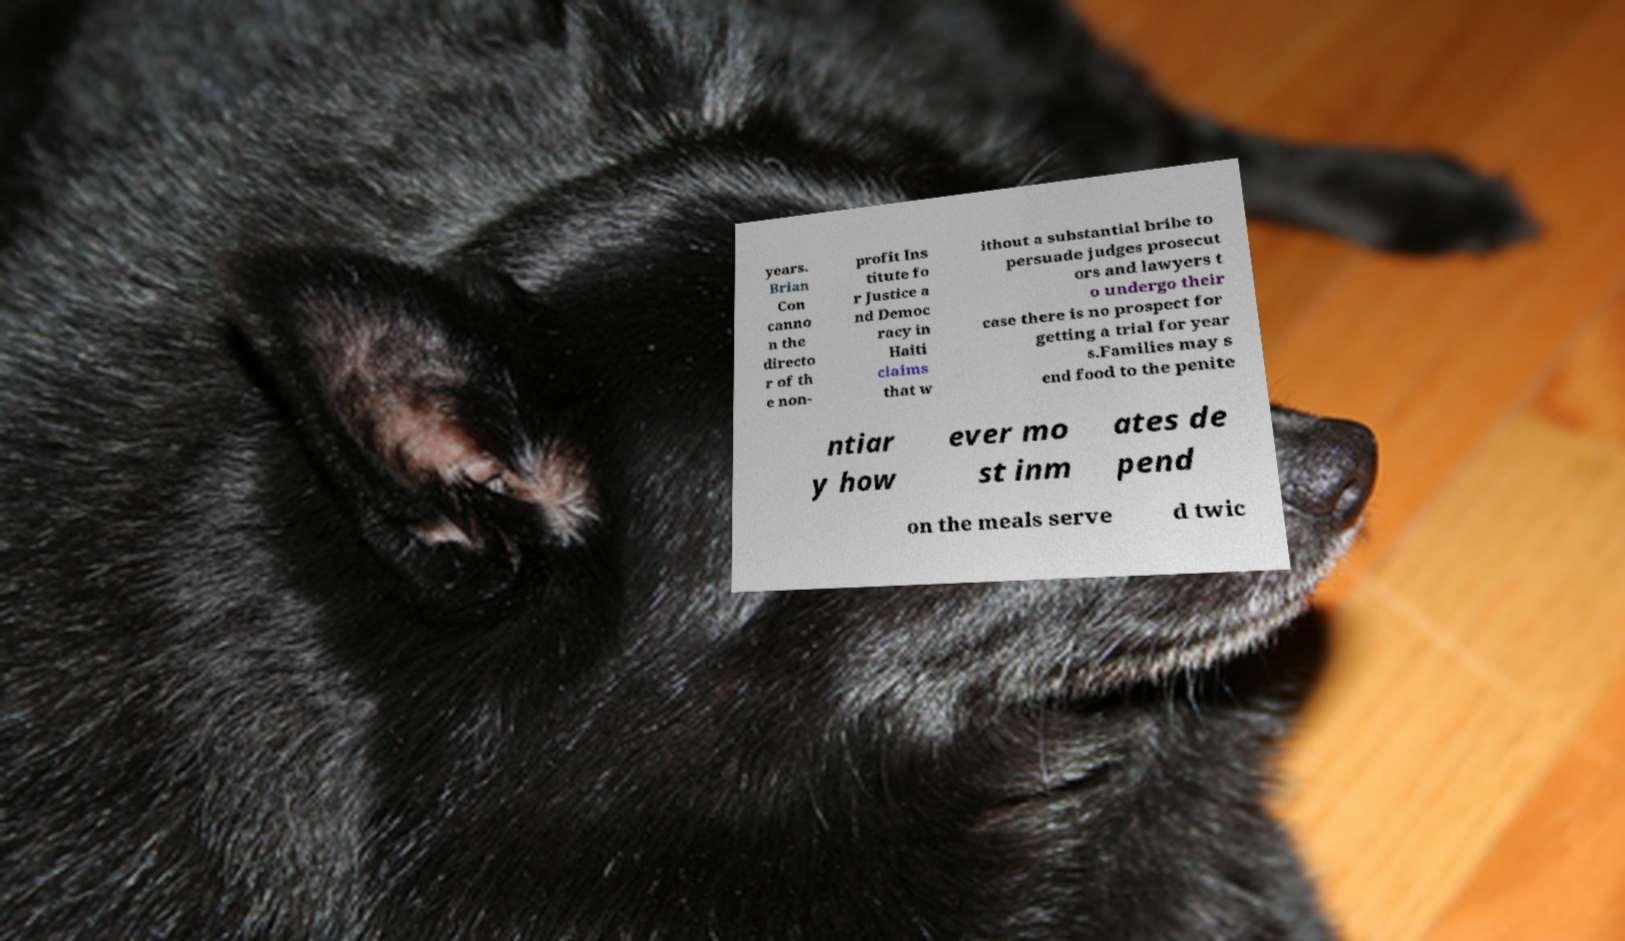Please identify and transcribe the text found in this image. years. Brian Con canno n the directo r of th e non- profit Ins titute fo r Justice a nd Democ racy in Haiti claims that w ithout a substantial bribe to persuade judges prosecut ors and lawyers t o undergo their case there is no prospect for getting a trial for year s.Families may s end food to the penite ntiar y how ever mo st inm ates de pend on the meals serve d twic 